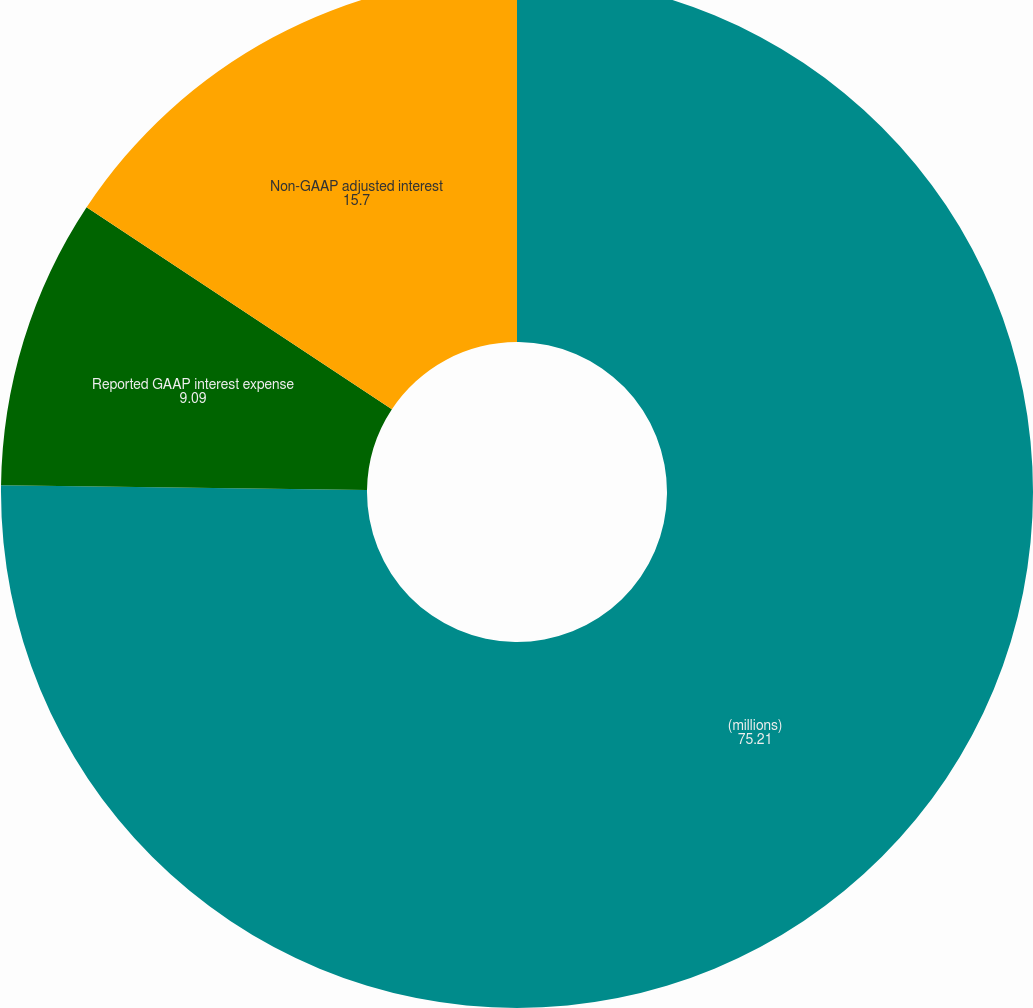Convert chart. <chart><loc_0><loc_0><loc_500><loc_500><pie_chart><fcel>(millions)<fcel>Reported GAAP interest expense<fcel>Non-GAAP adjusted interest<nl><fcel>75.21%<fcel>9.09%<fcel>15.7%<nl></chart> 